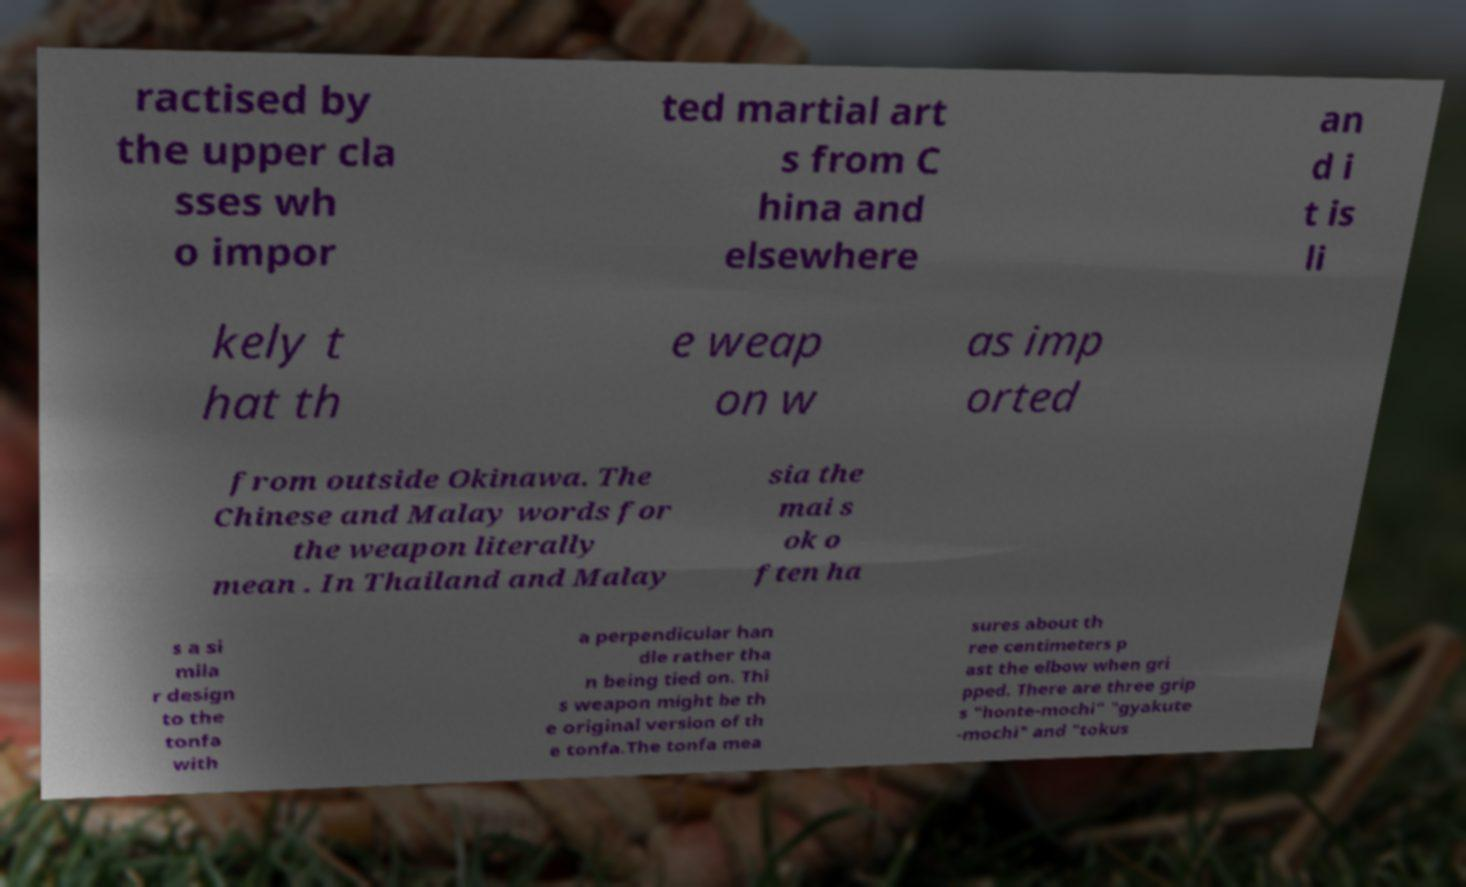Please read and relay the text visible in this image. What does it say? ractised by the upper cla sses wh o impor ted martial art s from C hina and elsewhere an d i t is li kely t hat th e weap on w as imp orted from outside Okinawa. The Chinese and Malay words for the weapon literally mean . In Thailand and Malay sia the mai s ok o ften ha s a si mila r design to the tonfa with a perpendicular han dle rather tha n being tied on. Thi s weapon might be th e original version of th e tonfa.The tonfa mea sures about th ree centimeters p ast the elbow when gri pped. There are three grip s "honte-mochi" "gyakute -mochi" and "tokus 